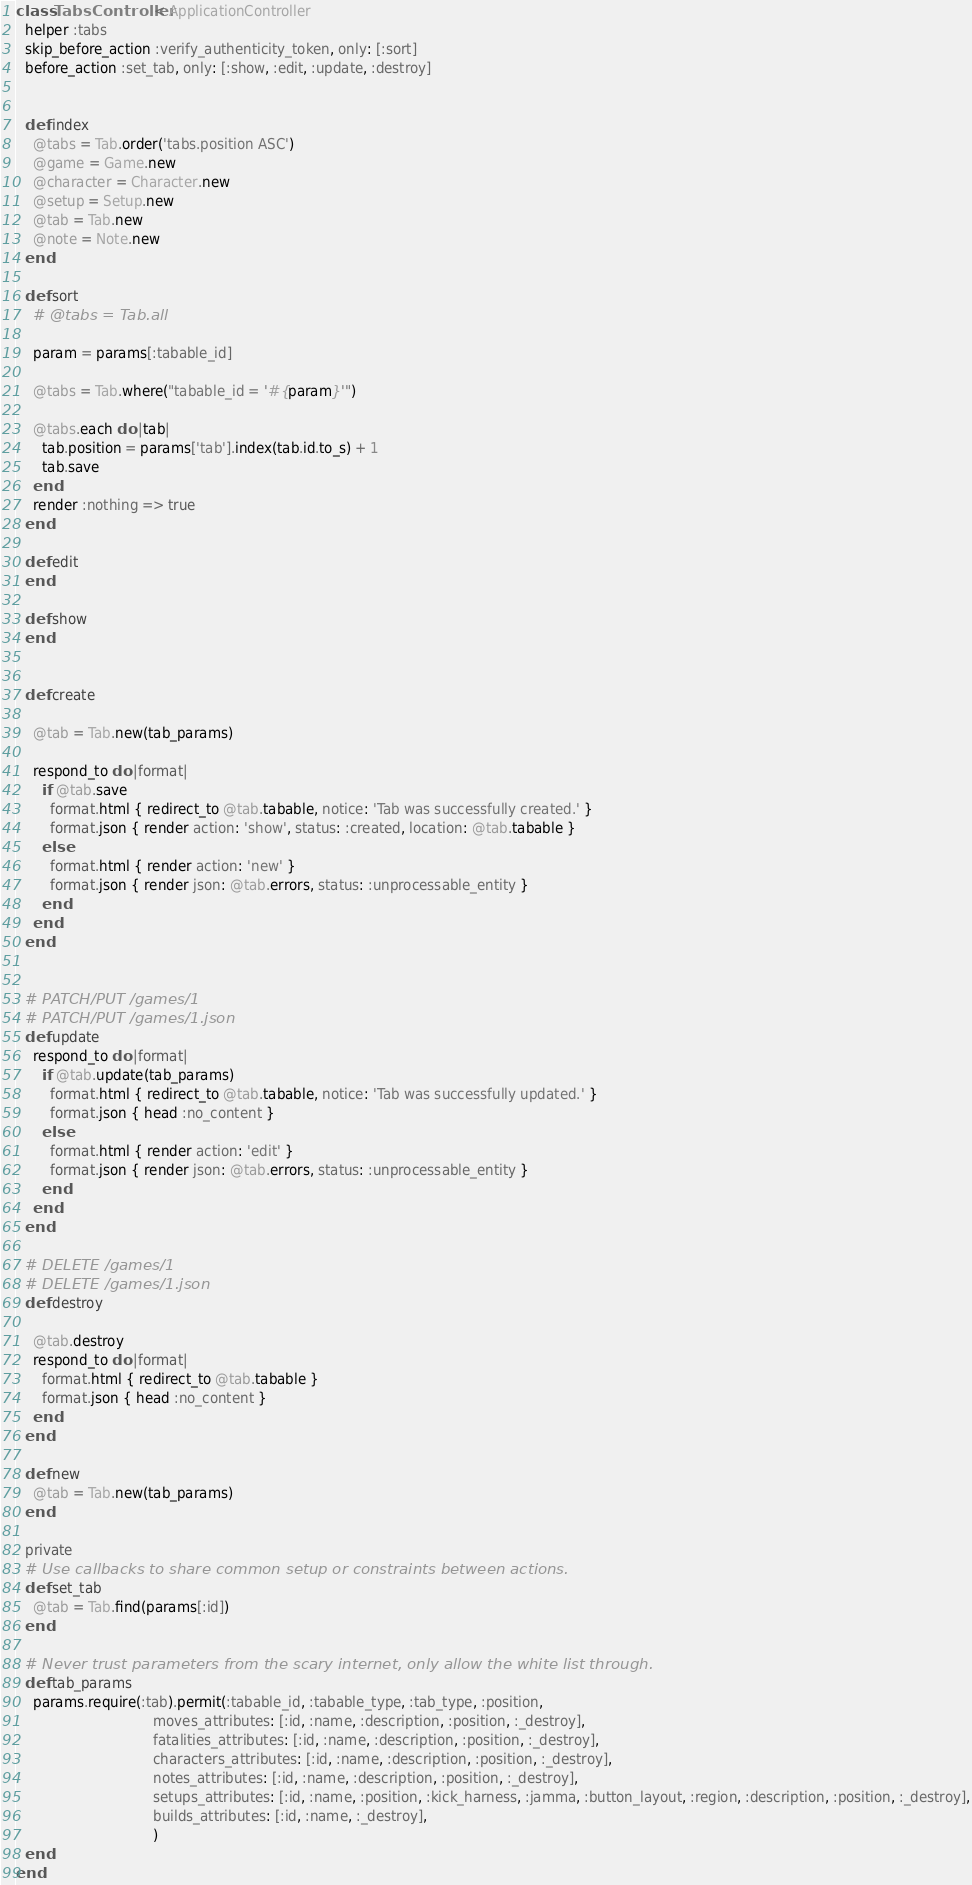Convert code to text. <code><loc_0><loc_0><loc_500><loc_500><_Ruby_>class TabsController < ApplicationController
  helper :tabs
  skip_before_action :verify_authenticity_token, only: [:sort]
  before_action :set_tab, only: [:show, :edit, :update, :destroy]


  def index
    @tabs = Tab.order('tabs.position ASC')
    @game = Game.new
    @character = Character.new
    @setup = Setup.new
    @tab = Tab.new
    @note = Note.new
  end

  def sort
    # @tabs = Tab.all

    param = params[:tabable_id]

    @tabs = Tab.where("tabable_id = '#{param}'")

    @tabs.each do |tab|
      tab.position = params['tab'].index(tab.id.to_s) + 1
      tab.save
    end
    render :nothing => true
  end

  def edit
  end

  def show
  end


  def create

    @tab = Tab.new(tab_params)

    respond_to do |format|
      if @tab.save
        format.html { redirect_to @tab.tabable, notice: 'Tab was successfully created.' }
        format.json { render action: 'show', status: :created, location: @tab.tabable }
      else
        format.html { render action: 'new' }
        format.json { render json: @tab.errors, status: :unprocessable_entity }
      end
    end
  end


  # PATCH/PUT /games/1
  # PATCH/PUT /games/1.json
  def update
    respond_to do |format|
      if @tab.update(tab_params)
        format.html { redirect_to @tab.tabable, notice: 'Tab was successfully updated.' }
        format.json { head :no_content }
      else
        format.html { render action: 'edit' }
        format.json { render json: @tab.errors, status: :unprocessable_entity }
      end
    end
  end

  # DELETE /games/1
  # DELETE /games/1.json
  def destroy

    @tab.destroy
    respond_to do |format|
      format.html { redirect_to @tab.tabable }
      format.json { head :no_content }
    end
  end

  def new
    @tab = Tab.new(tab_params)
  end

  private
  # Use callbacks to share common setup or constraints between actions.
  def set_tab
    @tab = Tab.find(params[:id])
  end

  # Never trust parameters from the scary internet, only allow the white list through.
  def tab_params
    params.require(:tab).permit(:tabable_id, :tabable_type, :tab_type, :position,
                                moves_attributes: [:id, :name, :description, :position, :_destroy],
                                fatalities_attributes: [:id, :name, :description, :position, :_destroy],
                                characters_attributes: [:id, :name, :description, :position, :_destroy],
                                notes_attributes: [:id, :name, :description, :position, :_destroy],
                                setups_attributes: [:id, :name, :position, :kick_harness, :jamma, :button_layout, :region, :description, :position, :_destroy],
                                builds_attributes: [:id, :name, :_destroy],
                                )
  end
end
</code> 